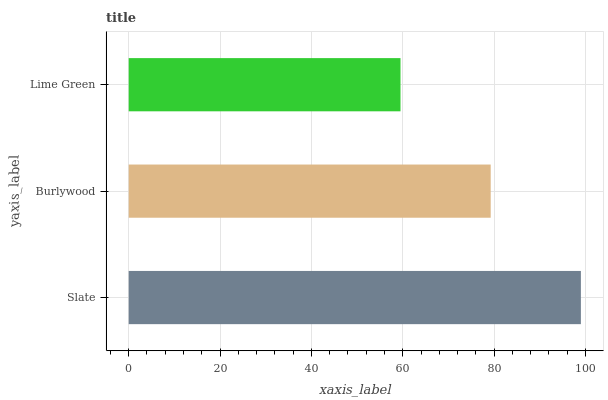Is Lime Green the minimum?
Answer yes or no. Yes. Is Slate the maximum?
Answer yes or no. Yes. Is Burlywood the minimum?
Answer yes or no. No. Is Burlywood the maximum?
Answer yes or no. No. Is Slate greater than Burlywood?
Answer yes or no. Yes. Is Burlywood less than Slate?
Answer yes or no. Yes. Is Burlywood greater than Slate?
Answer yes or no. No. Is Slate less than Burlywood?
Answer yes or no. No. Is Burlywood the high median?
Answer yes or no. Yes. Is Burlywood the low median?
Answer yes or no. Yes. Is Slate the high median?
Answer yes or no. No. Is Lime Green the low median?
Answer yes or no. No. 